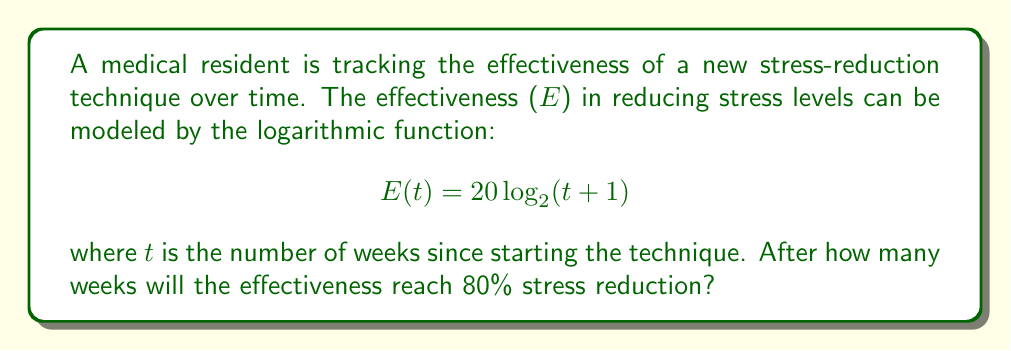Could you help me with this problem? To solve this problem, we need to follow these steps:

1) We're looking for the time t when E(t) = 80. So, we need to solve the equation:

   $$ 80 = 20 \log_2(t+1) $$

2) First, divide both sides by 20:

   $$ 4 = \log_2(t+1) $$

3) Now, we need to undo the logarithm. We can do this by raising 2 to the power of both sides:

   $$ 2^4 = 2^{\log_2(t+1)} $$

4) The left side simplifies to 16, and the right side simplifies to just (t+1):

   $$ 16 = t+1 $$

5) Finally, subtract 1 from both sides:

   $$ 15 = t $$

Therefore, the effectiveness will reach 80% after 15 weeks.
Answer: 15 weeks 